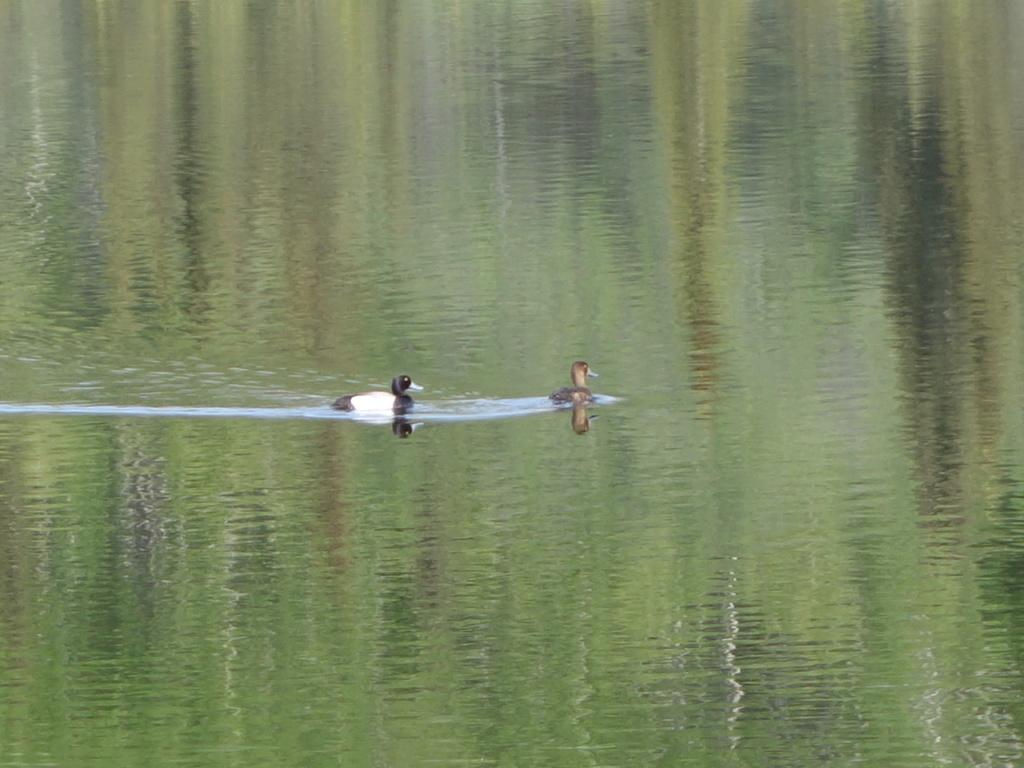How many ducks are present in the image? There are two ducks in the image. What are the ducks doing in the image? The ducks are moving on the water. What is the color of the water in the image? The water appears to be light greenish in color. What type of chair is the duck sitting on in the image? There is no chair present in the image, as the ducks are moving on the water. 